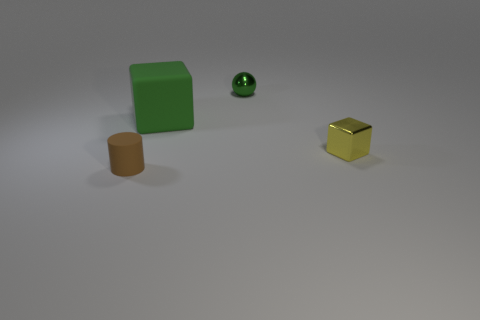Is there anything else that has the same shape as the large matte thing?
Ensure brevity in your answer.  Yes. There is a thing that is behind the large green cube; what is its material?
Ensure brevity in your answer.  Metal. Is there any other thing that is the same size as the cylinder?
Provide a short and direct response. Yes. There is a small cylinder; are there any tiny brown cylinders behind it?
Provide a short and direct response. No. What is the shape of the brown matte thing?
Provide a short and direct response. Cylinder. How many things are rubber things behind the brown rubber thing or small brown matte cylinders?
Provide a succinct answer. 2. What number of other things are there of the same color as the small ball?
Your answer should be compact. 1. There is a big matte object; is its color the same as the tiny thing that is right of the ball?
Offer a terse response. No. What color is the other object that is the same shape as the green rubber thing?
Offer a very short reply. Yellow. Is the material of the big green object the same as the tiny object behind the small yellow metal cube?
Provide a succinct answer. No. 